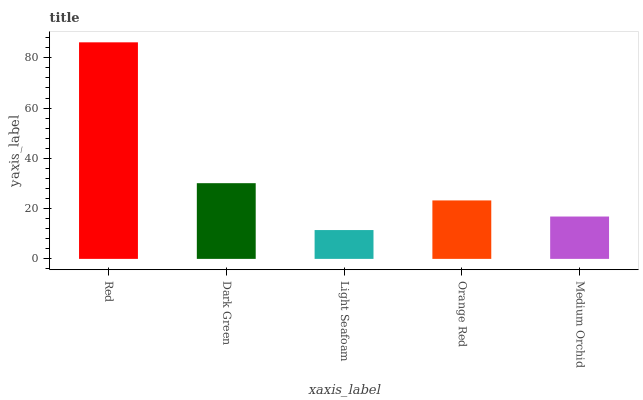Is Dark Green the minimum?
Answer yes or no. No. Is Dark Green the maximum?
Answer yes or no. No. Is Red greater than Dark Green?
Answer yes or no. Yes. Is Dark Green less than Red?
Answer yes or no. Yes. Is Dark Green greater than Red?
Answer yes or no. No. Is Red less than Dark Green?
Answer yes or no. No. Is Orange Red the high median?
Answer yes or no. Yes. Is Orange Red the low median?
Answer yes or no. Yes. Is Red the high median?
Answer yes or no. No. Is Light Seafoam the low median?
Answer yes or no. No. 